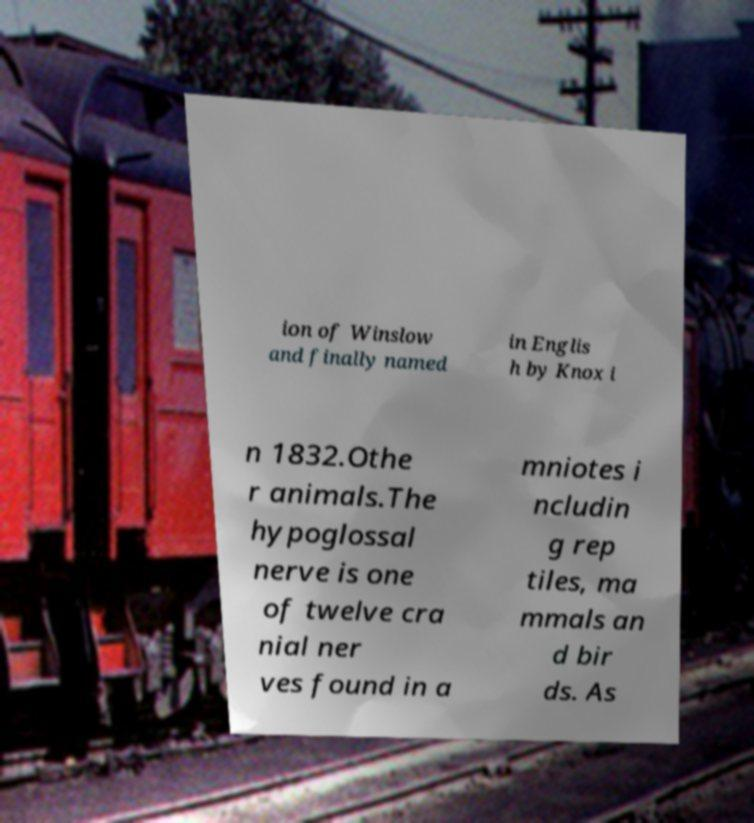Can you read and provide the text displayed in the image?This photo seems to have some interesting text. Can you extract and type it out for me? ion of Winslow and finally named in Englis h by Knox i n 1832.Othe r animals.The hypoglossal nerve is one of twelve cra nial ner ves found in a mniotes i ncludin g rep tiles, ma mmals an d bir ds. As 